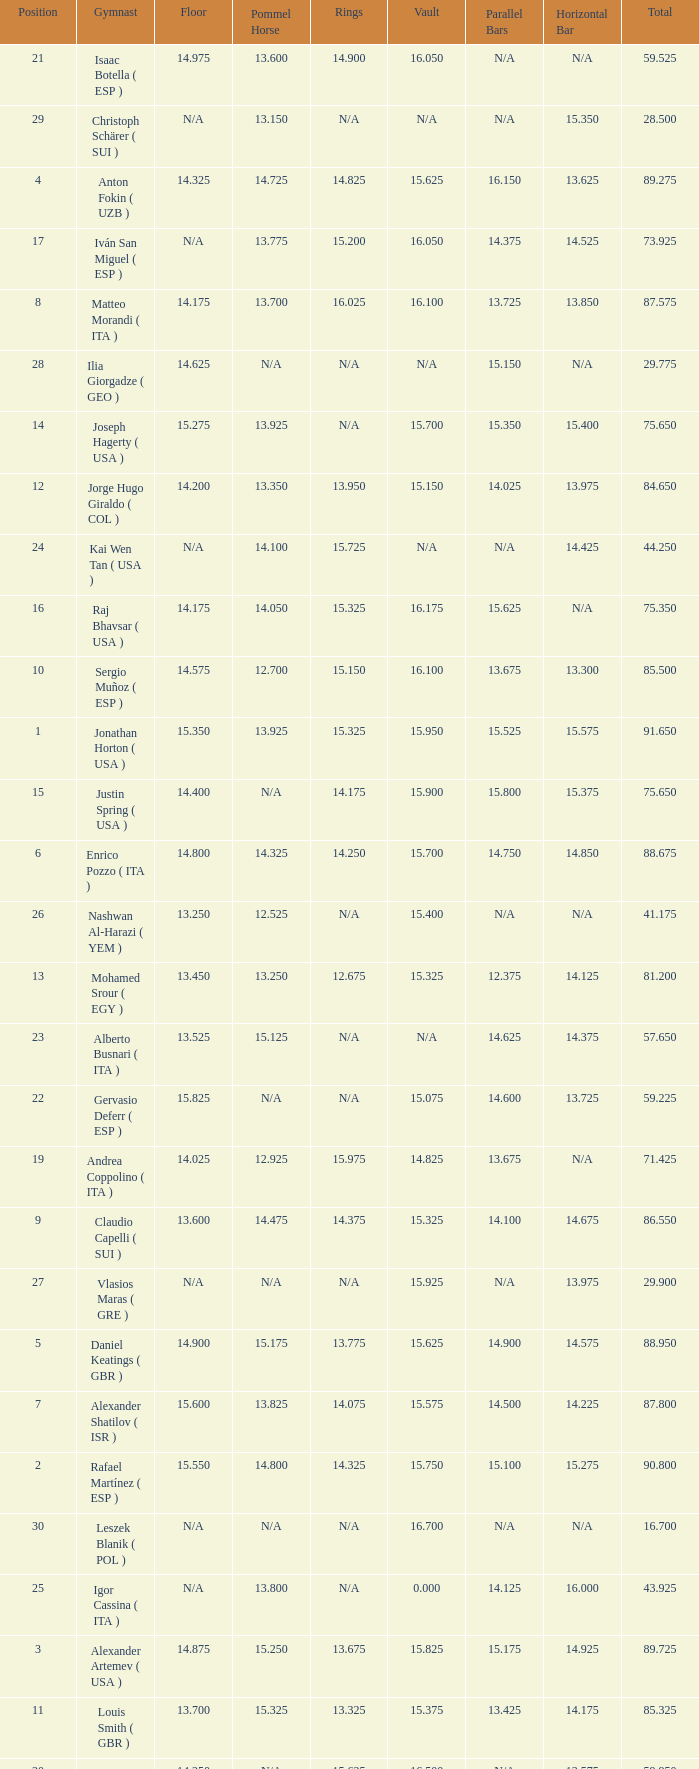If the parallel bars is 16.150, who is the gymnast? Anton Fokin ( UZB ). 